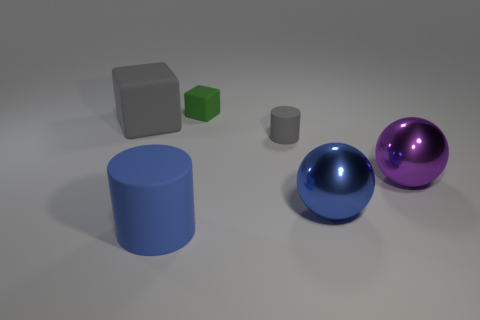Add 1 green matte blocks. How many objects exist? 7 Subtract all cubes. How many objects are left? 4 Add 5 balls. How many balls are left? 7 Add 3 blue metallic things. How many blue metallic things exist? 4 Subtract 0 cyan spheres. How many objects are left? 6 Subtract all tiny cyan rubber cylinders. Subtract all tiny rubber cylinders. How many objects are left? 5 